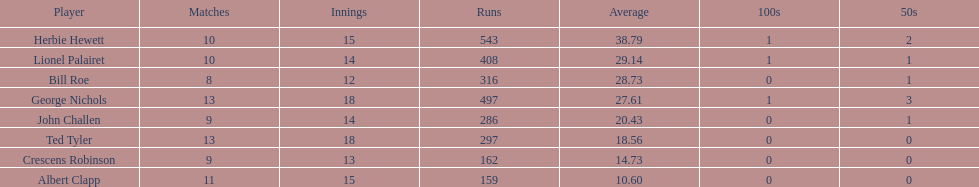What is the combined innings count for bill and ted? 30. 